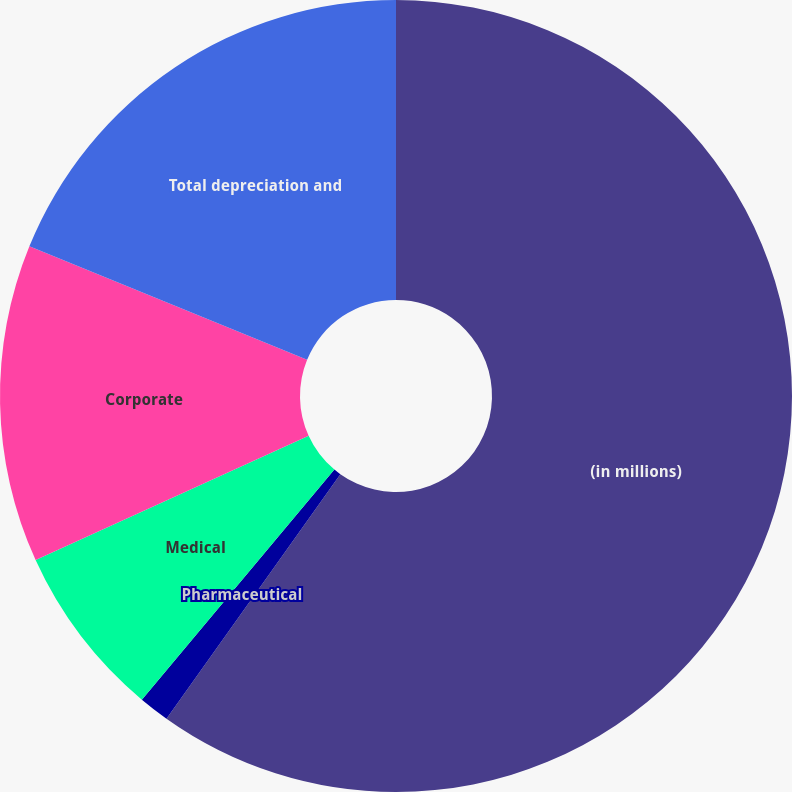Convert chart to OTSL. <chart><loc_0><loc_0><loc_500><loc_500><pie_chart><fcel>(in millions)<fcel>Pharmaceutical<fcel>Medical<fcel>Corporate<fcel>Total depreciation and<nl><fcel>59.84%<fcel>1.25%<fcel>7.11%<fcel>12.97%<fcel>18.83%<nl></chart> 